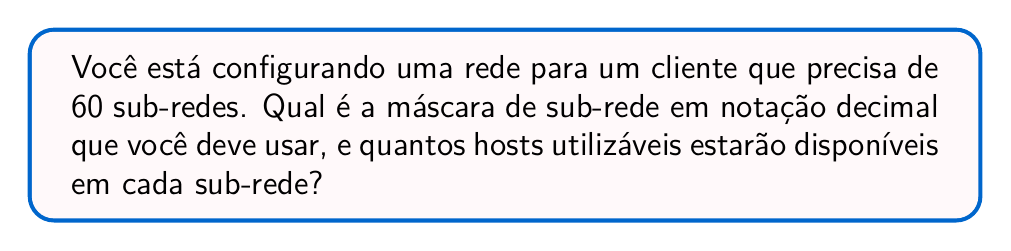Solve this math problem. Para resolver este problema, vamos seguir estes passos:

1) Primeiro, precisamos determinar quantos bits são necessários para representar 60 sub-redes.

   $2^5 = 32$ (não é suficiente)
   $2^6 = 64$ (suficiente)

   Portanto, precisamos de 6 bits para as sub-redes.

2) Em um endereço IP de classe C, temos 8 bits disponíveis para sub-redes e hosts. Se usamos 6 para sub-redes, sobram 2 para hosts.

3) A máscara de sub-rede seria então:

   11111111.11111111.11111111.11111100

4) Para converter isso para notação decimal, dividimos em octetos:

   11111111.11111111.11111111.11111100
      255  .   255  .   255  .   252

5) Portanto, a máscara de sub-rede em notação decimal é 255.255.255.252

6) Para calcular o número de hosts utilizáveis:

   Com 2 bits para hosts, temos $2^2 = 4$ endereços possíveis.
   Subtraímos 2 (endereço de rede e broadcast), ficamos com 2 hosts utilizáveis por sub-rede.
Answer: A máscara de sub-rede é 255.255.255.252, e cada sub-rede terá 2 hosts utilizáveis. 